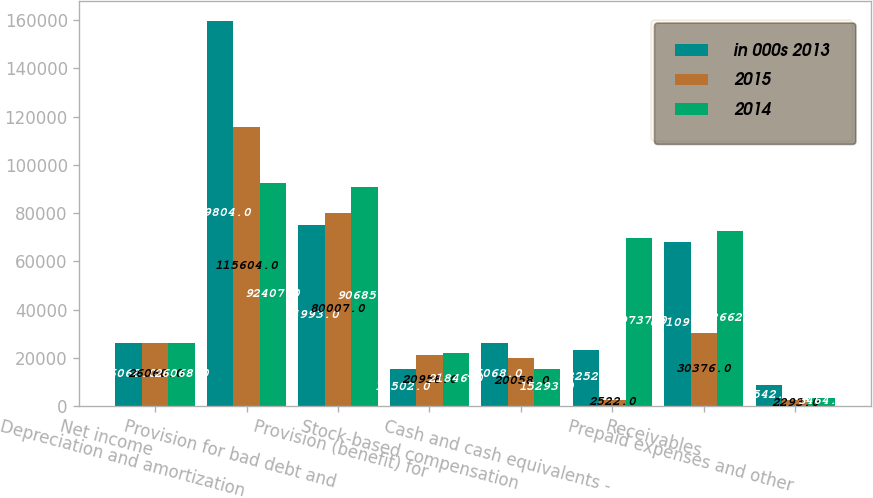<chart> <loc_0><loc_0><loc_500><loc_500><stacked_bar_chart><ecel><fcel>Net income<fcel>Depreciation and amortization<fcel>Provision for bad debt and<fcel>Provision (benefit) for<fcel>Stock-based compensation<fcel>Cash and cash equivalents -<fcel>Receivables<fcel>Prepaid expenses and other<nl><fcel>in 000s 2013<fcel>26068<fcel>159804<fcel>74993<fcel>15502<fcel>26068<fcel>23252<fcel>68109<fcel>8542<nl><fcel>2015<fcel>26068<fcel>115604<fcel>80007<fcel>20958<fcel>20058<fcel>2522<fcel>30376<fcel>2293<nl><fcel>2014<fcel>26068<fcel>92407<fcel>90685<fcel>21846<fcel>15293<fcel>69737<fcel>72662<fcel>3464<nl></chart> 